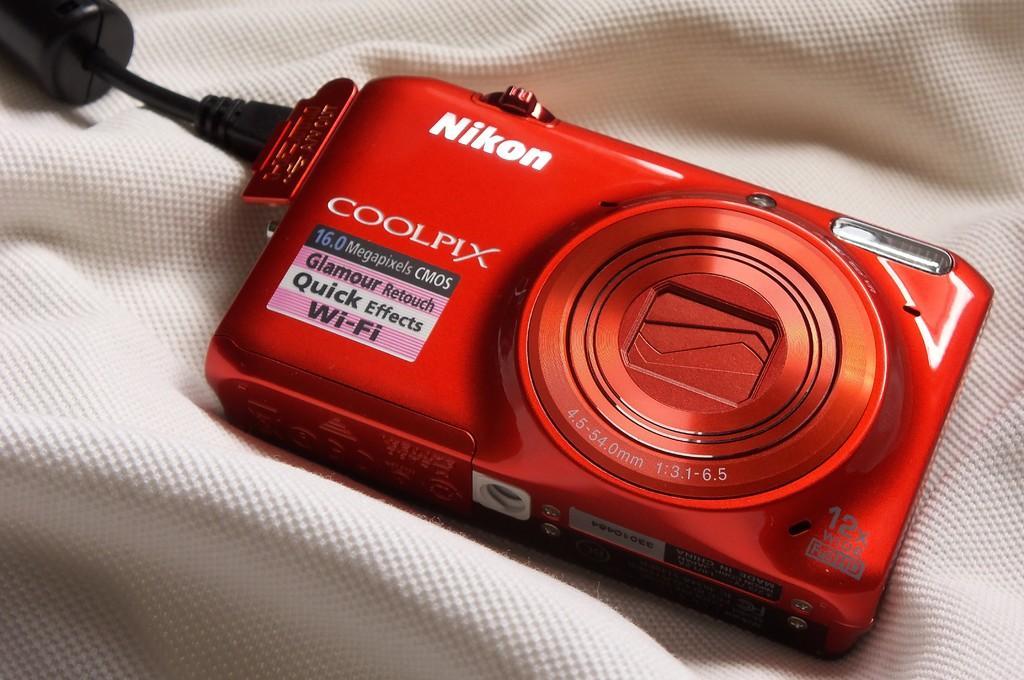Describe this image in one or two sentences. In this picture I can see there is a camera in red color on a white color. On the left side there is the cable in black color. 